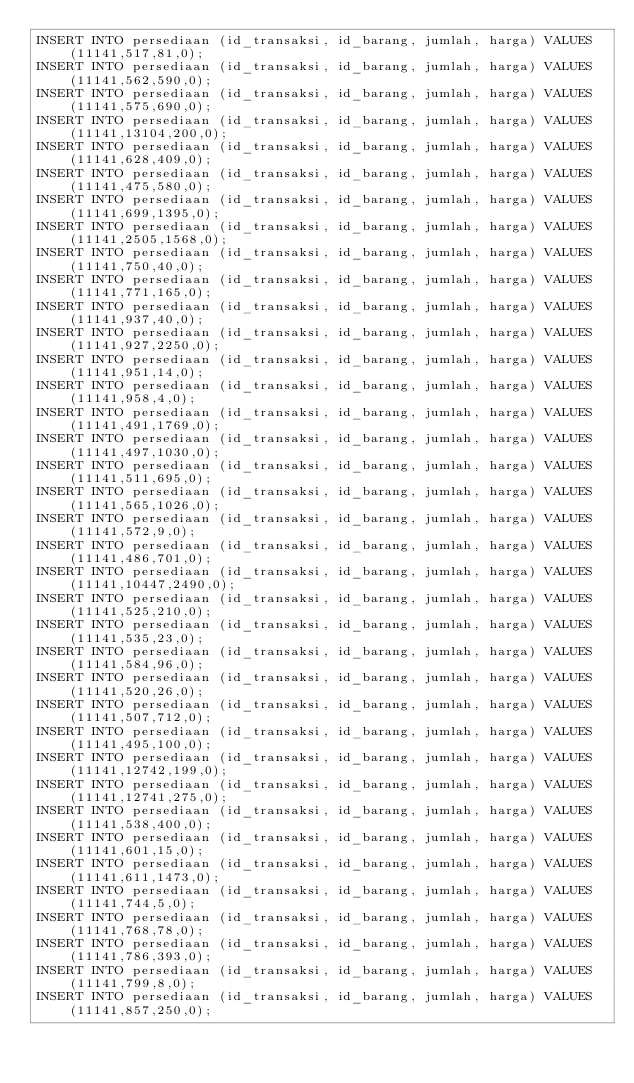<code> <loc_0><loc_0><loc_500><loc_500><_SQL_>INSERT INTO persediaan (id_transaksi, id_barang, jumlah, harga) VALUES (11141,517,81,0);
INSERT INTO persediaan (id_transaksi, id_barang, jumlah, harga) VALUES (11141,562,590,0);
INSERT INTO persediaan (id_transaksi, id_barang, jumlah, harga) VALUES (11141,575,690,0);
INSERT INTO persediaan (id_transaksi, id_barang, jumlah, harga) VALUES (11141,13104,200,0);
INSERT INTO persediaan (id_transaksi, id_barang, jumlah, harga) VALUES (11141,628,409,0);
INSERT INTO persediaan (id_transaksi, id_barang, jumlah, harga) VALUES (11141,475,580,0);
INSERT INTO persediaan (id_transaksi, id_barang, jumlah, harga) VALUES (11141,699,1395,0);
INSERT INTO persediaan (id_transaksi, id_barang, jumlah, harga) VALUES (11141,2505,1568,0);
INSERT INTO persediaan (id_transaksi, id_barang, jumlah, harga) VALUES (11141,750,40,0);
INSERT INTO persediaan (id_transaksi, id_barang, jumlah, harga) VALUES (11141,771,165,0);
INSERT INTO persediaan (id_transaksi, id_barang, jumlah, harga) VALUES (11141,937,40,0);
INSERT INTO persediaan (id_transaksi, id_barang, jumlah, harga) VALUES (11141,927,2250,0);
INSERT INTO persediaan (id_transaksi, id_barang, jumlah, harga) VALUES (11141,951,14,0);
INSERT INTO persediaan (id_transaksi, id_barang, jumlah, harga) VALUES (11141,958,4,0);
INSERT INTO persediaan (id_transaksi, id_barang, jumlah, harga) VALUES (11141,491,1769,0);
INSERT INTO persediaan (id_transaksi, id_barang, jumlah, harga) VALUES (11141,497,1030,0);
INSERT INTO persediaan (id_transaksi, id_barang, jumlah, harga) VALUES (11141,511,695,0);
INSERT INTO persediaan (id_transaksi, id_barang, jumlah, harga) VALUES (11141,565,1026,0);
INSERT INTO persediaan (id_transaksi, id_barang, jumlah, harga) VALUES (11141,572,9,0);
INSERT INTO persediaan (id_transaksi, id_barang, jumlah, harga) VALUES (11141,486,701,0);
INSERT INTO persediaan (id_transaksi, id_barang, jumlah, harga) VALUES (11141,10447,2490,0);
INSERT INTO persediaan (id_transaksi, id_barang, jumlah, harga) VALUES (11141,525,210,0);
INSERT INTO persediaan (id_transaksi, id_barang, jumlah, harga) VALUES (11141,535,23,0);
INSERT INTO persediaan (id_transaksi, id_barang, jumlah, harga) VALUES (11141,584,96,0);
INSERT INTO persediaan (id_transaksi, id_barang, jumlah, harga) VALUES (11141,520,26,0);
INSERT INTO persediaan (id_transaksi, id_barang, jumlah, harga) VALUES (11141,507,712,0);
INSERT INTO persediaan (id_transaksi, id_barang, jumlah, harga) VALUES (11141,495,100,0);
INSERT INTO persediaan (id_transaksi, id_barang, jumlah, harga) VALUES (11141,12742,199,0);
INSERT INTO persediaan (id_transaksi, id_barang, jumlah, harga) VALUES (11141,12741,275,0);
INSERT INTO persediaan (id_transaksi, id_barang, jumlah, harga) VALUES (11141,538,400,0);
INSERT INTO persediaan (id_transaksi, id_barang, jumlah, harga) VALUES (11141,601,15,0);
INSERT INTO persediaan (id_transaksi, id_barang, jumlah, harga) VALUES (11141,611,1473,0);
INSERT INTO persediaan (id_transaksi, id_barang, jumlah, harga) VALUES (11141,744,5,0);
INSERT INTO persediaan (id_transaksi, id_barang, jumlah, harga) VALUES (11141,768,78,0);
INSERT INTO persediaan (id_transaksi, id_barang, jumlah, harga) VALUES (11141,786,393,0);
INSERT INTO persediaan (id_transaksi, id_barang, jumlah, harga) VALUES (11141,799,8,0);
INSERT INTO persediaan (id_transaksi, id_barang, jumlah, harga) VALUES (11141,857,250,0);</code> 